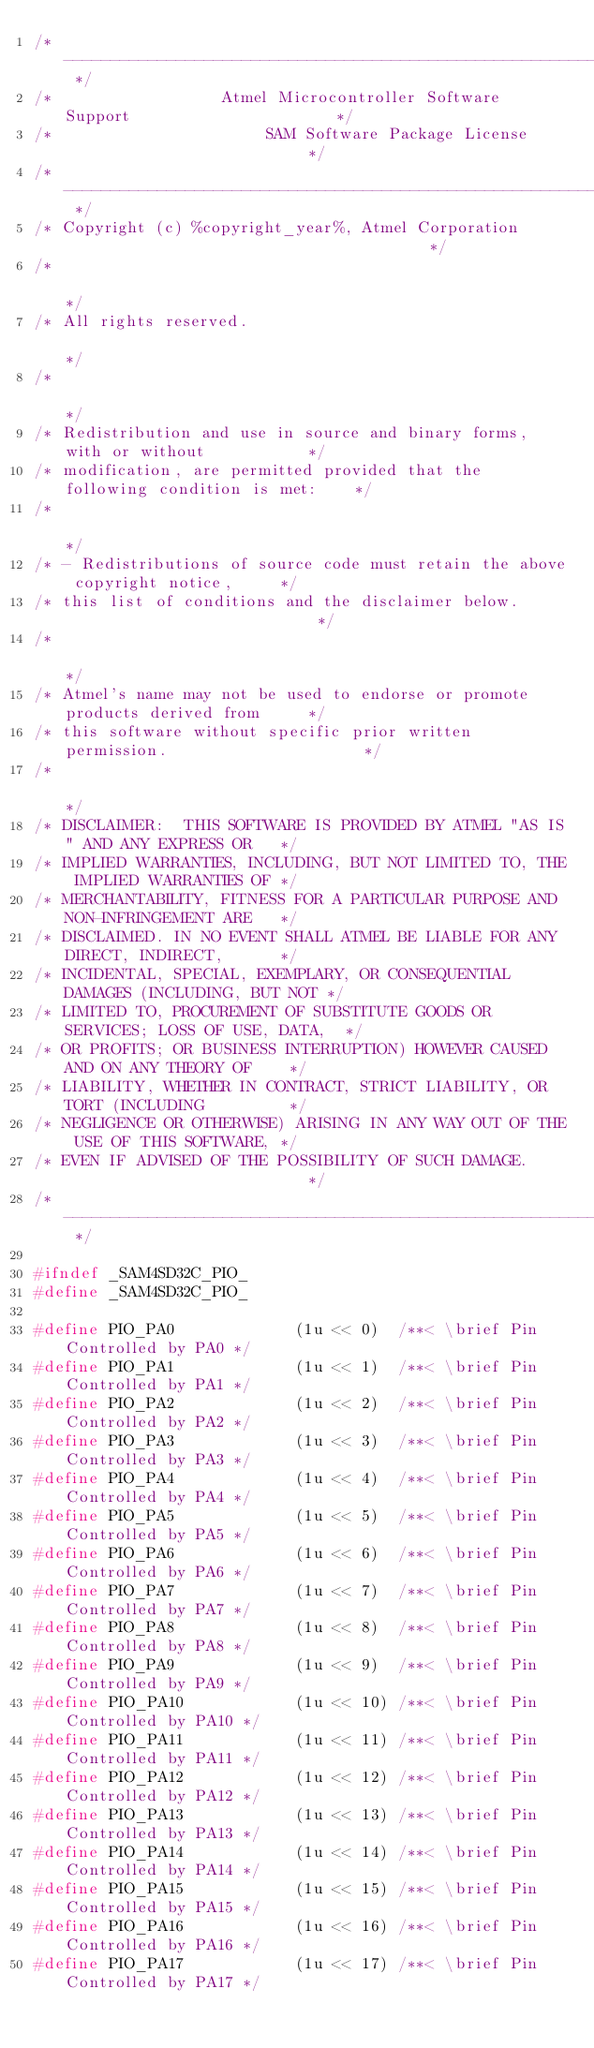<code> <loc_0><loc_0><loc_500><loc_500><_C_>/* ---------------------------------------------------------------------------- */
/*                  Atmel Microcontroller Software Support                      */
/*                       SAM Software Package License                           */
/* ---------------------------------------------------------------------------- */
/* Copyright (c) %copyright_year%, Atmel Corporation                                        */
/*                                                                              */
/* All rights reserved.                                                         */
/*                                                                              */
/* Redistribution and use in source and binary forms, with or without           */
/* modification, are permitted provided that the following condition is met:    */
/*                                                                              */
/* - Redistributions of source code must retain the above copyright notice,     */
/* this list of conditions and the disclaimer below.                            */
/*                                                                              */
/* Atmel's name may not be used to endorse or promote products derived from     */
/* this software without specific prior written permission.                     */
/*                                                                              */
/* DISCLAIMER:  THIS SOFTWARE IS PROVIDED BY ATMEL "AS IS" AND ANY EXPRESS OR   */
/* IMPLIED WARRANTIES, INCLUDING, BUT NOT LIMITED TO, THE IMPLIED WARRANTIES OF */
/* MERCHANTABILITY, FITNESS FOR A PARTICULAR PURPOSE AND NON-INFRINGEMENT ARE   */
/* DISCLAIMED. IN NO EVENT SHALL ATMEL BE LIABLE FOR ANY DIRECT, INDIRECT,      */
/* INCIDENTAL, SPECIAL, EXEMPLARY, OR CONSEQUENTIAL DAMAGES (INCLUDING, BUT NOT */
/* LIMITED TO, PROCUREMENT OF SUBSTITUTE GOODS OR SERVICES; LOSS OF USE, DATA,  */
/* OR PROFITS; OR BUSINESS INTERRUPTION) HOWEVER CAUSED AND ON ANY THEORY OF    */
/* LIABILITY, WHETHER IN CONTRACT, STRICT LIABILITY, OR TORT (INCLUDING         */
/* NEGLIGENCE OR OTHERWISE) ARISING IN ANY WAY OUT OF THE USE OF THIS SOFTWARE, */
/* EVEN IF ADVISED OF THE POSSIBILITY OF SUCH DAMAGE.                           */
/* ---------------------------------------------------------------------------- */

#ifndef _SAM4SD32C_PIO_
#define _SAM4SD32C_PIO_

#define PIO_PA0             (1u << 0)  /**< \brief Pin Controlled by PA0 */
#define PIO_PA1             (1u << 1)  /**< \brief Pin Controlled by PA1 */
#define PIO_PA2             (1u << 2)  /**< \brief Pin Controlled by PA2 */
#define PIO_PA3             (1u << 3)  /**< \brief Pin Controlled by PA3 */
#define PIO_PA4             (1u << 4)  /**< \brief Pin Controlled by PA4 */
#define PIO_PA5             (1u << 5)  /**< \brief Pin Controlled by PA5 */
#define PIO_PA6             (1u << 6)  /**< \brief Pin Controlled by PA6 */
#define PIO_PA7             (1u << 7)  /**< \brief Pin Controlled by PA7 */
#define PIO_PA8             (1u << 8)  /**< \brief Pin Controlled by PA8 */
#define PIO_PA9             (1u << 9)  /**< \brief Pin Controlled by PA9 */
#define PIO_PA10            (1u << 10) /**< \brief Pin Controlled by PA10 */
#define PIO_PA11            (1u << 11) /**< \brief Pin Controlled by PA11 */
#define PIO_PA12            (1u << 12) /**< \brief Pin Controlled by PA12 */
#define PIO_PA13            (1u << 13) /**< \brief Pin Controlled by PA13 */
#define PIO_PA14            (1u << 14) /**< \brief Pin Controlled by PA14 */
#define PIO_PA15            (1u << 15) /**< \brief Pin Controlled by PA15 */
#define PIO_PA16            (1u << 16) /**< \brief Pin Controlled by PA16 */
#define PIO_PA17            (1u << 17) /**< \brief Pin Controlled by PA17 */</code> 